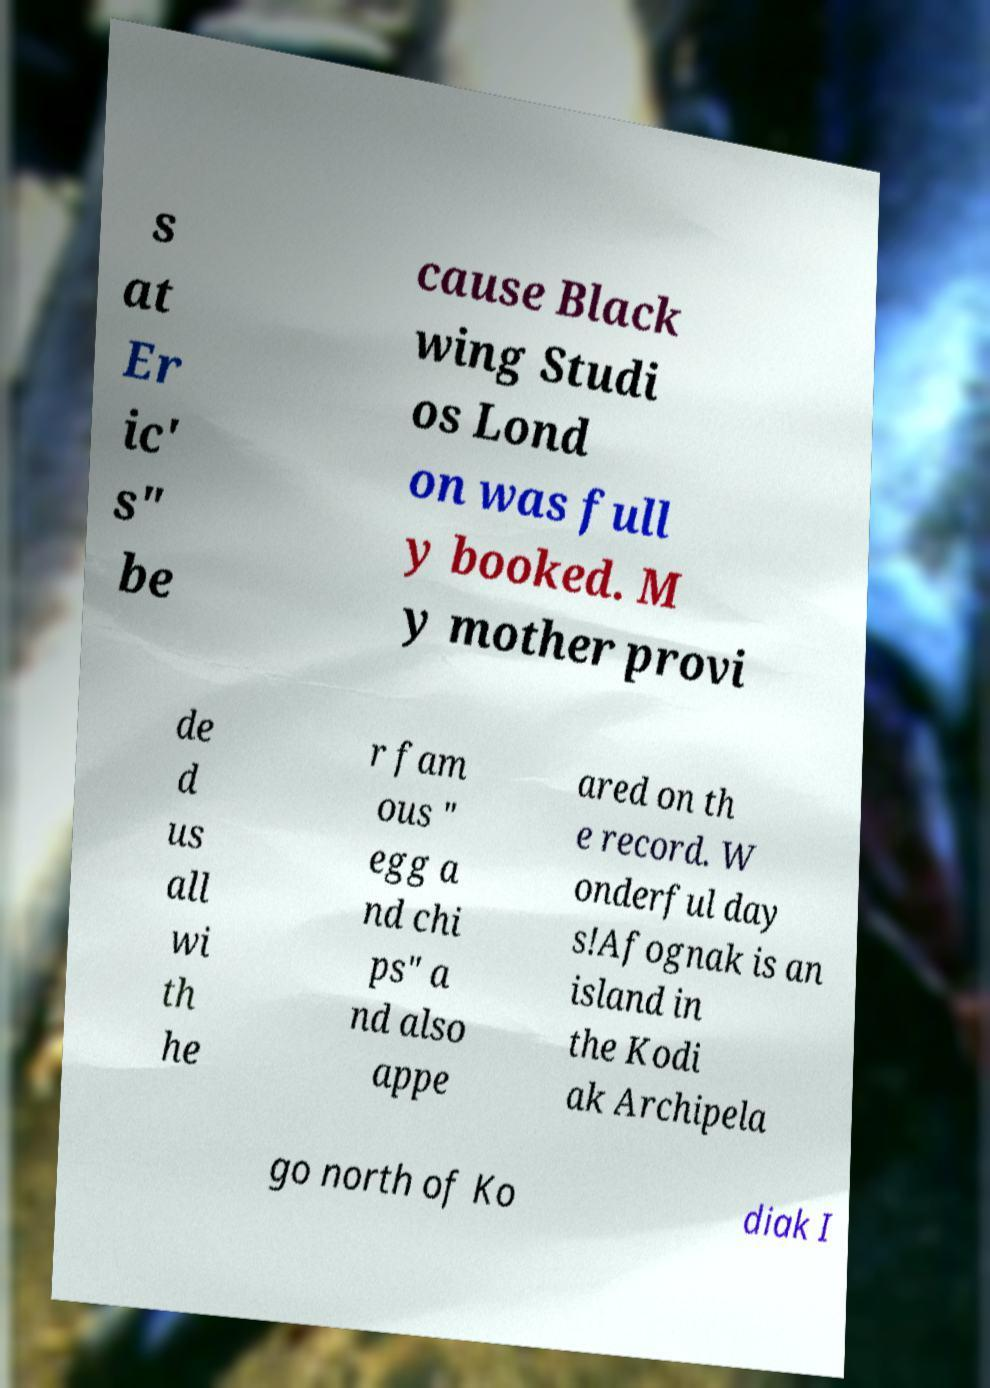There's text embedded in this image that I need extracted. Can you transcribe it verbatim? s at Er ic' s" be cause Black wing Studi os Lond on was full y booked. M y mother provi de d us all wi th he r fam ous " egg a nd chi ps" a nd also appe ared on th e record. W onderful day s!Afognak is an island in the Kodi ak Archipela go north of Ko diak I 